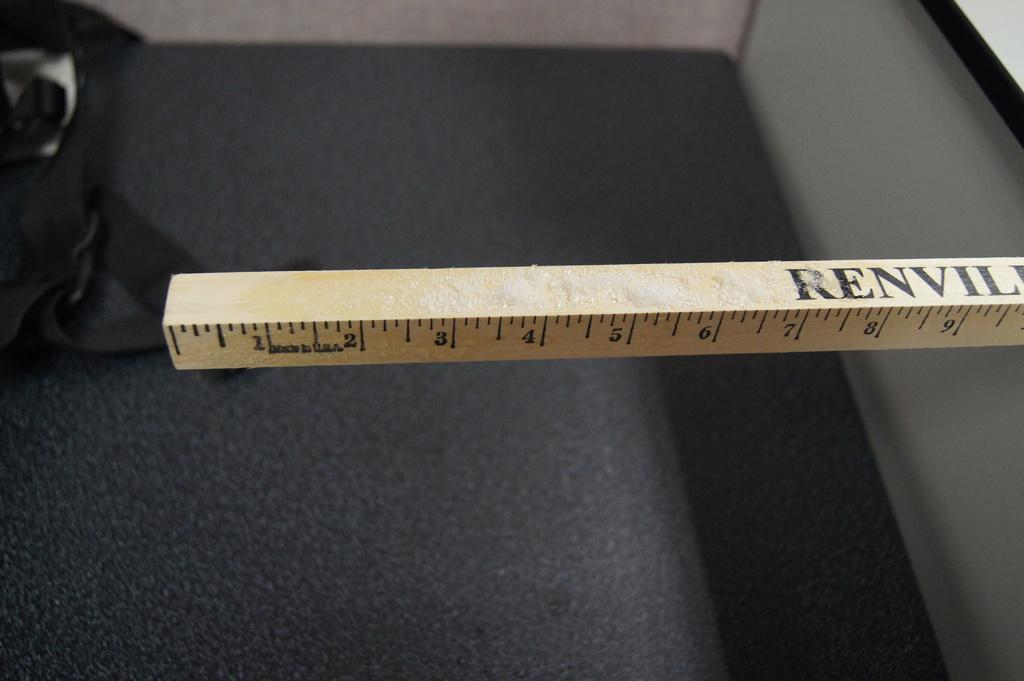<image>
Render a clear and concise summary of the photo. Almost ten inches of a square ruler with Renvil on it. 